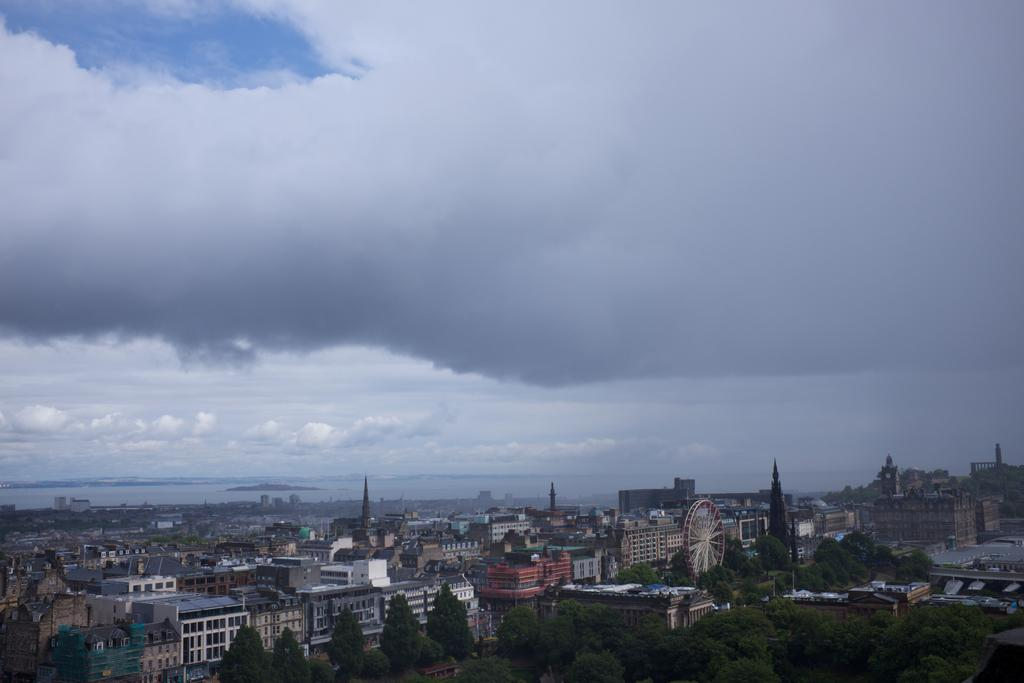What type of vegetation can be seen in the image? There are trees in the image. What type of structures are present in the image? There are buildings in the image. What can be seen in the sky in the image? There are clouds visible in the image. What part of the natural environment is visible in the image? The sky is visible in the image. How many apples are hanging from the clouds in the image? There are no apples present in the image, and they are not hanging from the clouds. What type of shade is provided by the clouds in the image? There is no mention of shade in the image, and the clouds are not providing any shade. 